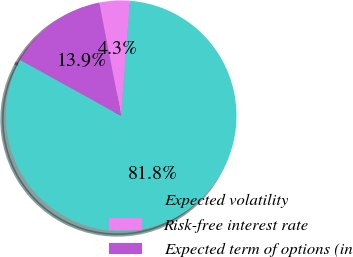<chart> <loc_0><loc_0><loc_500><loc_500><pie_chart><fcel>Expected volatility<fcel>Risk-free interest rate<fcel>Expected term of options (in<nl><fcel>81.82%<fcel>4.28%<fcel>13.9%<nl></chart> 